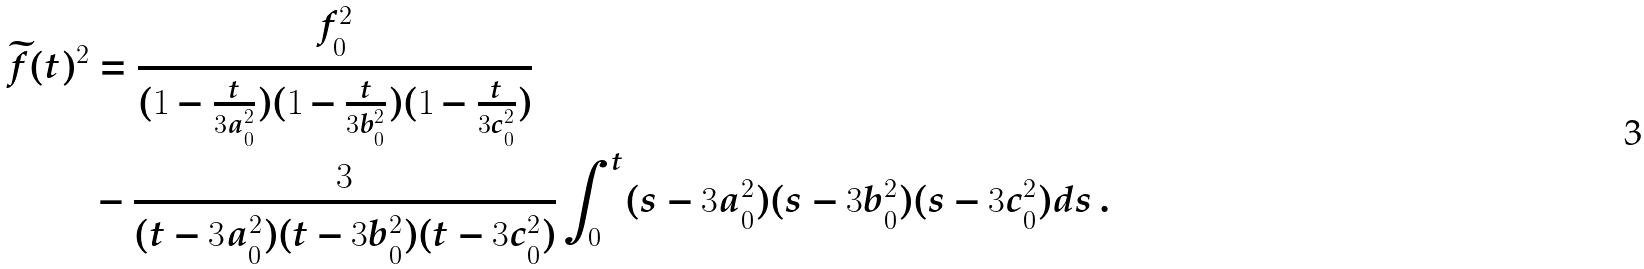<formula> <loc_0><loc_0><loc_500><loc_500>\widetilde { f } ( t ) ^ { 2 } & = \frac { f _ { 0 } ^ { 2 } } { ( 1 - \frac { t } { 3 a _ { 0 } ^ { 2 } } ) ( 1 - \frac { t } { 3 b _ { 0 } ^ { 2 } } ) ( 1 - \frac { t } { 3 c _ { 0 } ^ { 2 } } ) } \\ & - \frac { 3 } { ( t - 3 a _ { 0 } ^ { 2 } ) ( t - 3 b _ { 0 } ^ { 2 } ) ( t - 3 c _ { 0 } ^ { 2 } ) } \int _ { 0 } ^ { t } ( s - 3 a _ { 0 } ^ { 2 } ) ( s - 3 b _ { 0 } ^ { 2 } ) ( s - 3 c _ { 0 } ^ { 2 } ) d s \, . \\</formula> 